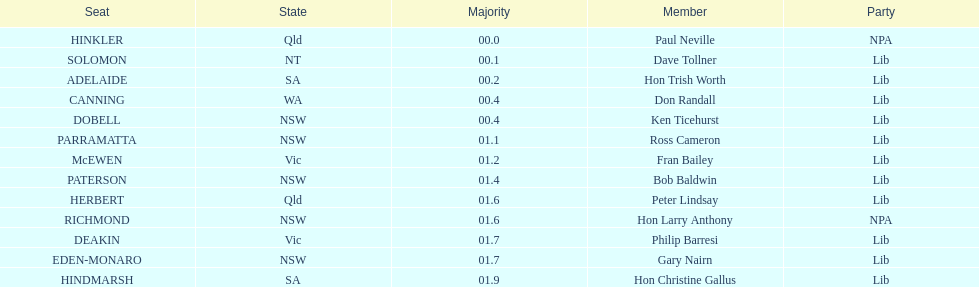Was fran bailey's home state victoria or western australia? Vic. 